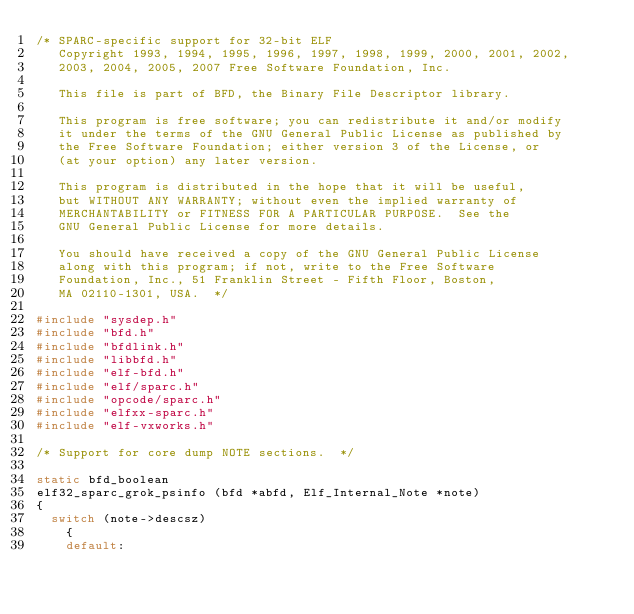Convert code to text. <code><loc_0><loc_0><loc_500><loc_500><_C_>/* SPARC-specific support for 32-bit ELF
   Copyright 1993, 1994, 1995, 1996, 1997, 1998, 1999, 2000, 2001, 2002,
   2003, 2004, 2005, 2007 Free Software Foundation, Inc.

   This file is part of BFD, the Binary File Descriptor library.

   This program is free software; you can redistribute it and/or modify
   it under the terms of the GNU General Public License as published by
   the Free Software Foundation; either version 3 of the License, or
   (at your option) any later version.

   This program is distributed in the hope that it will be useful,
   but WITHOUT ANY WARRANTY; without even the implied warranty of
   MERCHANTABILITY or FITNESS FOR A PARTICULAR PURPOSE.  See the
   GNU General Public License for more details.

   You should have received a copy of the GNU General Public License
   along with this program; if not, write to the Free Software
   Foundation, Inc., 51 Franklin Street - Fifth Floor, Boston,
   MA 02110-1301, USA.  */

#include "sysdep.h"
#include "bfd.h"
#include "bfdlink.h"
#include "libbfd.h"
#include "elf-bfd.h"
#include "elf/sparc.h"
#include "opcode/sparc.h"
#include "elfxx-sparc.h"
#include "elf-vxworks.h"

/* Support for core dump NOTE sections.  */

static bfd_boolean
elf32_sparc_grok_psinfo (bfd *abfd, Elf_Internal_Note *note)
{
  switch (note->descsz)
    {
    default:</code> 